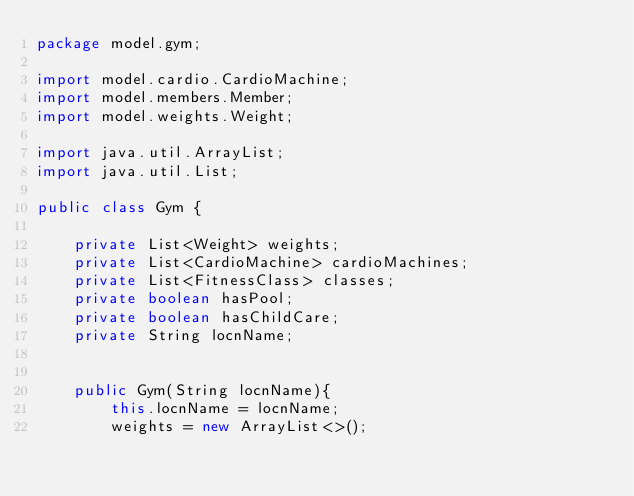Convert code to text. <code><loc_0><loc_0><loc_500><loc_500><_Java_>package model.gym;

import model.cardio.CardioMachine;
import model.members.Member;
import model.weights.Weight;

import java.util.ArrayList;
import java.util.List;

public class Gym {

    private List<Weight> weights;
    private List<CardioMachine> cardioMachines;
    private List<FitnessClass> classes;
    private boolean hasPool;
    private boolean hasChildCare;
    private String locnName;


    public Gym(String locnName){
        this.locnName = locnName;
        weights = new ArrayList<>();</code> 